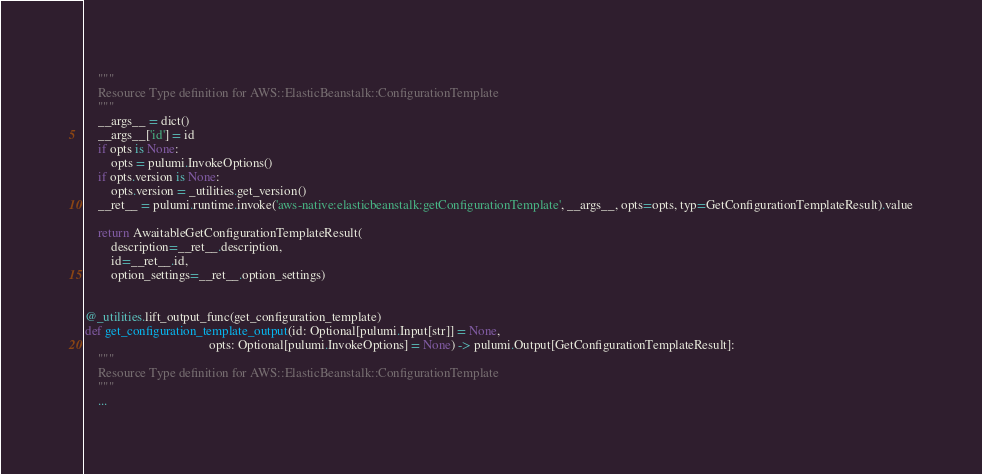Convert code to text. <code><loc_0><loc_0><loc_500><loc_500><_Python_>    """
    Resource Type definition for AWS::ElasticBeanstalk::ConfigurationTemplate
    """
    __args__ = dict()
    __args__['id'] = id
    if opts is None:
        opts = pulumi.InvokeOptions()
    if opts.version is None:
        opts.version = _utilities.get_version()
    __ret__ = pulumi.runtime.invoke('aws-native:elasticbeanstalk:getConfigurationTemplate', __args__, opts=opts, typ=GetConfigurationTemplateResult).value

    return AwaitableGetConfigurationTemplateResult(
        description=__ret__.description,
        id=__ret__.id,
        option_settings=__ret__.option_settings)


@_utilities.lift_output_func(get_configuration_template)
def get_configuration_template_output(id: Optional[pulumi.Input[str]] = None,
                                      opts: Optional[pulumi.InvokeOptions] = None) -> pulumi.Output[GetConfigurationTemplateResult]:
    """
    Resource Type definition for AWS::ElasticBeanstalk::ConfigurationTemplate
    """
    ...
</code> 